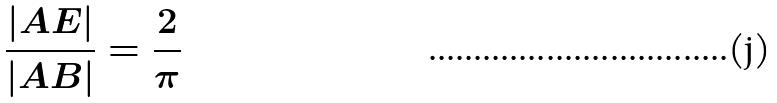<formula> <loc_0><loc_0><loc_500><loc_500>\frac { | A E | } { | A B | } = \frac { 2 } { \pi }</formula> 